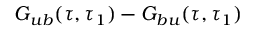<formula> <loc_0><loc_0><loc_500><loc_500>G _ { u b } ( \tau , \tau _ { 1 } ) - G _ { b u } ( \tau , \tau _ { 1 } )</formula> 